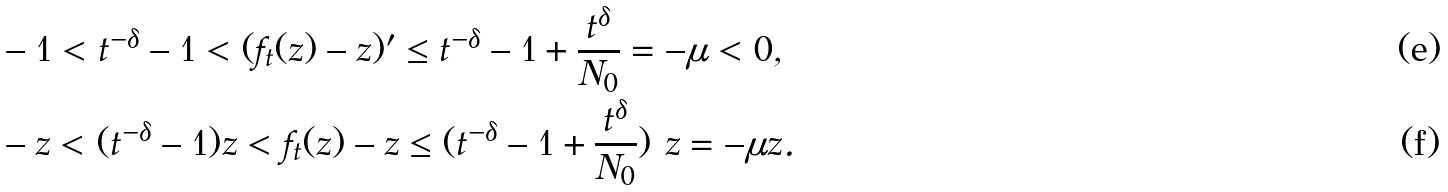<formula> <loc_0><loc_0><loc_500><loc_500>& - 1 < t ^ { - \delta } - 1 < ( f _ { t } ( z ) - z ) ^ { \prime } \leq t ^ { - \delta } - 1 + \frac { t ^ { \delta } } { N _ { 0 } } = - \mu < 0 , \\ & - z < ( t ^ { - \delta } - 1 ) z < f _ { t } ( z ) - z \leq ( t ^ { - \delta } - 1 + \frac { t ^ { \delta } } { N _ { 0 } } ) \ z = - \mu z .</formula> 